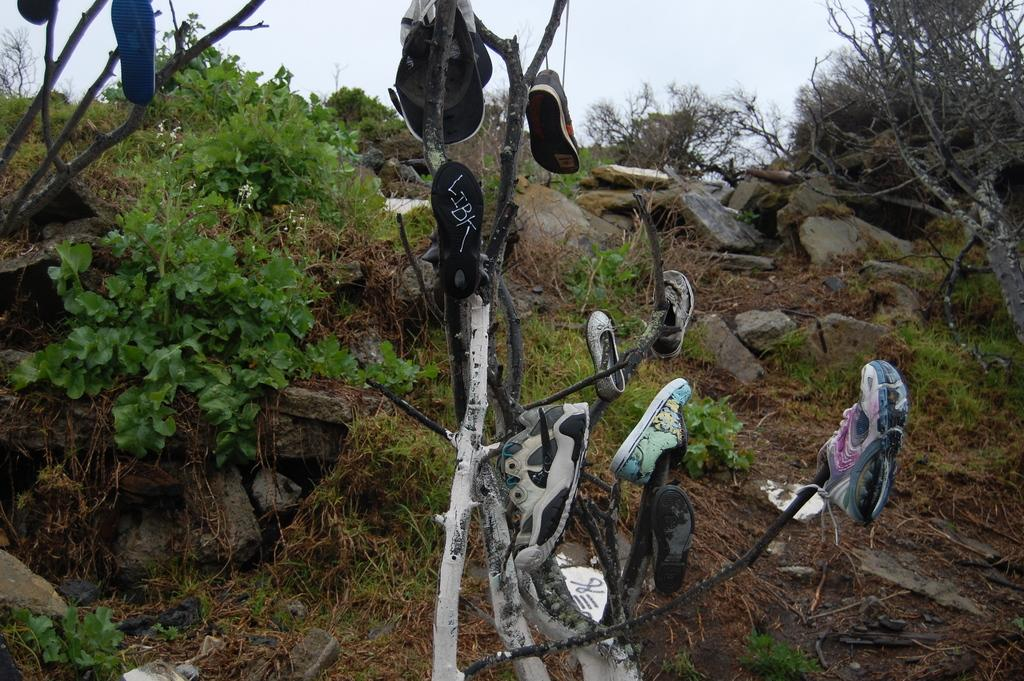What objects are hanging from the branches of a tree in the image? There is a cap and shoes hanging from the branches of a tree in the image. What type of vegetation is present in the image? There are trees, plants, and grass in the image. What other objects can be seen in the image? There are rocks in the image. What is visible in the background of the image? The sky is visible in the image. What type of jewel is the secretary wearing in the image? There is no secretary or jewel present in the image. 